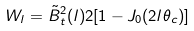<formula> <loc_0><loc_0><loc_500><loc_500>W _ { l } = \tilde { B } _ { t } ^ { 2 } ( l ) 2 [ 1 - J _ { 0 } ( 2 l \theta _ { c } ) ]</formula> 